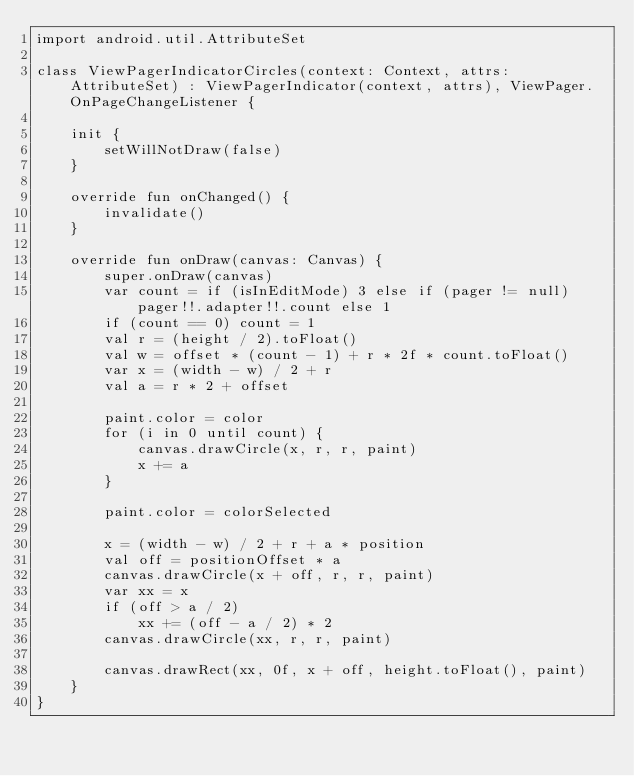<code> <loc_0><loc_0><loc_500><loc_500><_Kotlin_>import android.util.AttributeSet

class ViewPagerIndicatorCircles(context: Context, attrs: AttributeSet) : ViewPagerIndicator(context, attrs), ViewPager.OnPageChangeListener {

    init {
        setWillNotDraw(false)
    }

    override fun onChanged() {
        invalidate()
    }

    override fun onDraw(canvas: Canvas) {
        super.onDraw(canvas)
        var count = if (isInEditMode) 3 else if (pager != null) pager!!.adapter!!.count else 1
        if (count == 0) count = 1
        val r = (height / 2).toFloat()
        val w = offset * (count - 1) + r * 2f * count.toFloat()
        var x = (width - w) / 2 + r
        val a = r * 2 + offset

        paint.color = color
        for (i in 0 until count) {
            canvas.drawCircle(x, r, r, paint)
            x += a
        }

        paint.color = colorSelected

        x = (width - w) / 2 + r + a * position
        val off = positionOffset * a
        canvas.drawCircle(x + off, r, r, paint)
        var xx = x
        if (off > a / 2)
            xx += (off - a / 2) * 2
        canvas.drawCircle(xx, r, r, paint)

        canvas.drawRect(xx, 0f, x + off, height.toFloat(), paint)
    }
}
</code> 